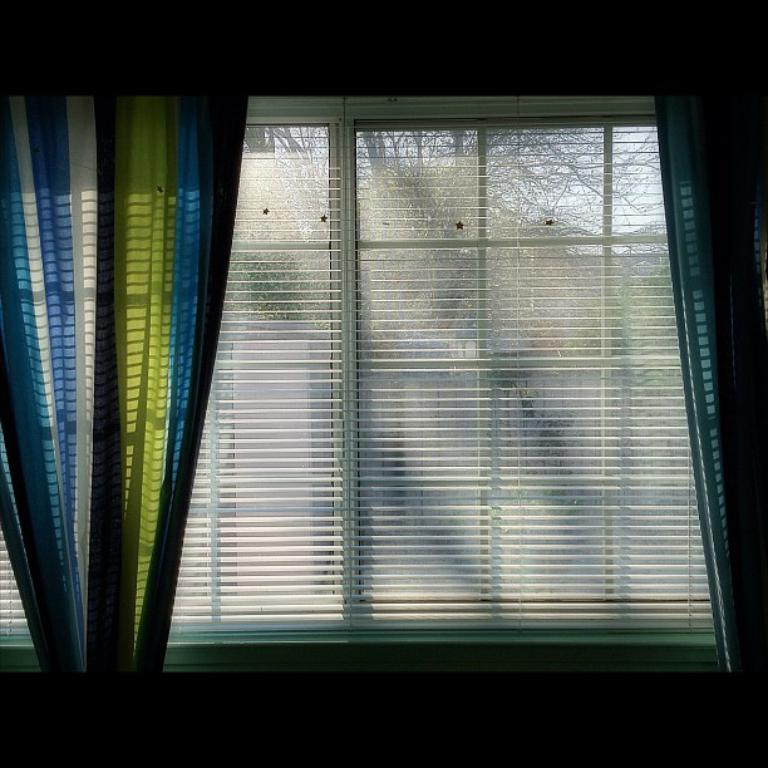What type of window treatment is present in the image? There are curtains in the image. What is located near the curtains in the image? There is a window in the image. What can be seen through the window in the image? Trees are visible through the window in the image. What type of meal is being prepared in the wilderness, as seen through the window in the image? There is no wilderness or meal preparation visible in the image; it only shows curtains, a window, and trees through the window. 